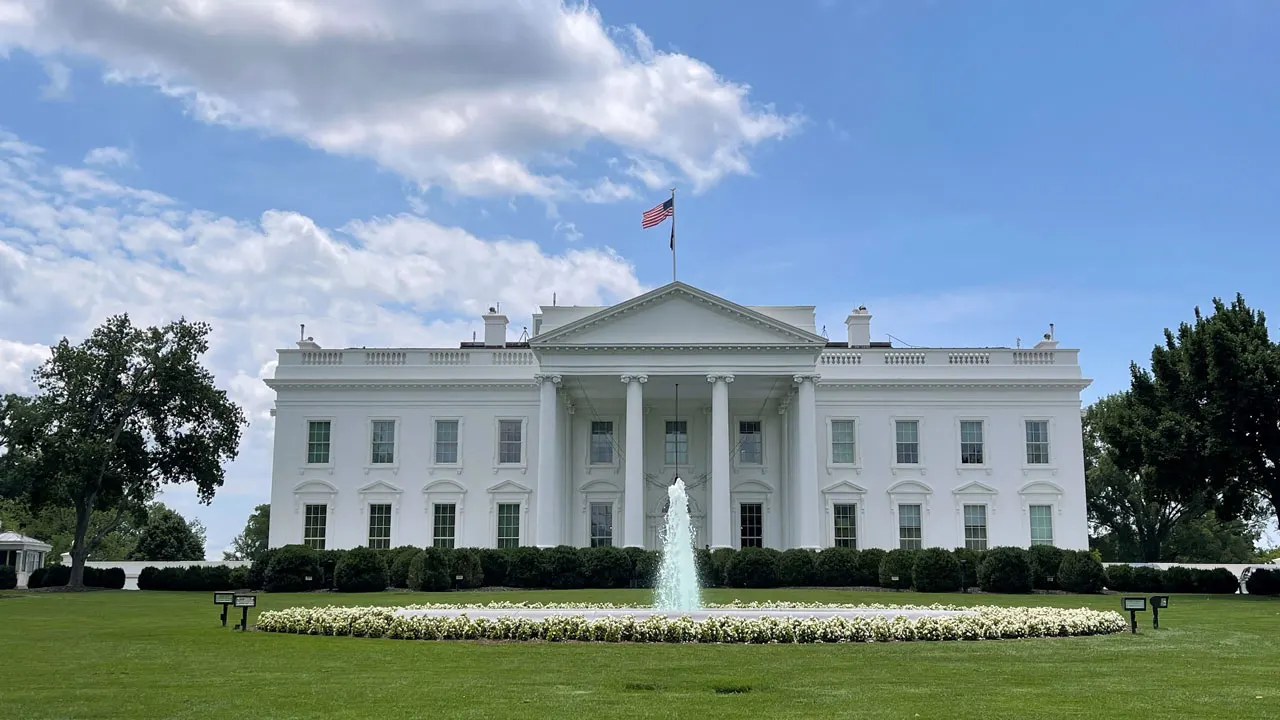What can you tell me about the history of the building in this image? The White House, with its neoclassical style, was designed by architect James Hoban and constructed between 1792 and 1800. It has been the residence of every U.S. president since John Adams. The building has undergone numerous renovations and expansions, including the rebuilding after being set ablaze by the British Army during the War of 1812. Beyond its function as a residence, it has been a stage for historic events and decisions, from the signing of pivotal legislation to hosting foreign dignitaries. 